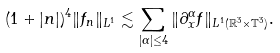Convert formula to latex. <formula><loc_0><loc_0><loc_500><loc_500>( 1 + | { n } | ) ^ { 4 } \| f _ { n } \| _ { L ^ { 1 } } \lesssim \sum _ { | \alpha | \leq 4 } \| \partial _ { x } ^ { \alpha } f \| _ { L ^ { 1 } ( \mathbb { R } ^ { 3 } \times \mathbb { T } ^ { 3 } ) } .</formula> 